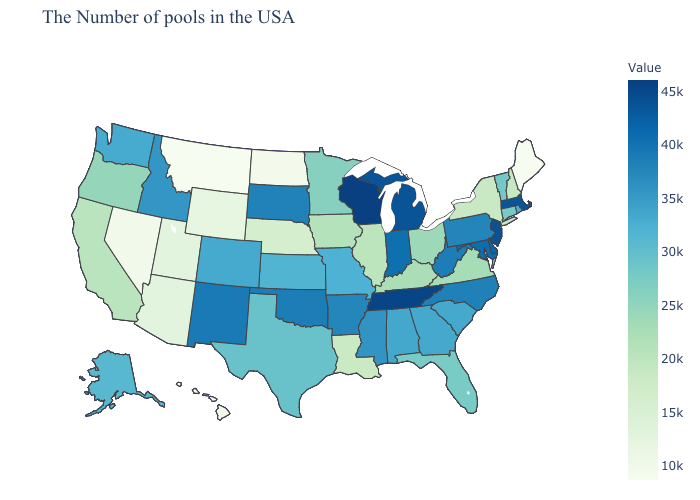Does Iowa have a lower value than West Virginia?
Write a very short answer. Yes. Does Maine have the lowest value in the USA?
Answer briefly. Yes. Among the states that border Wyoming , does Colorado have the lowest value?
Short answer required. No. Does Tennessee have the highest value in the South?
Quick response, please. Yes. 